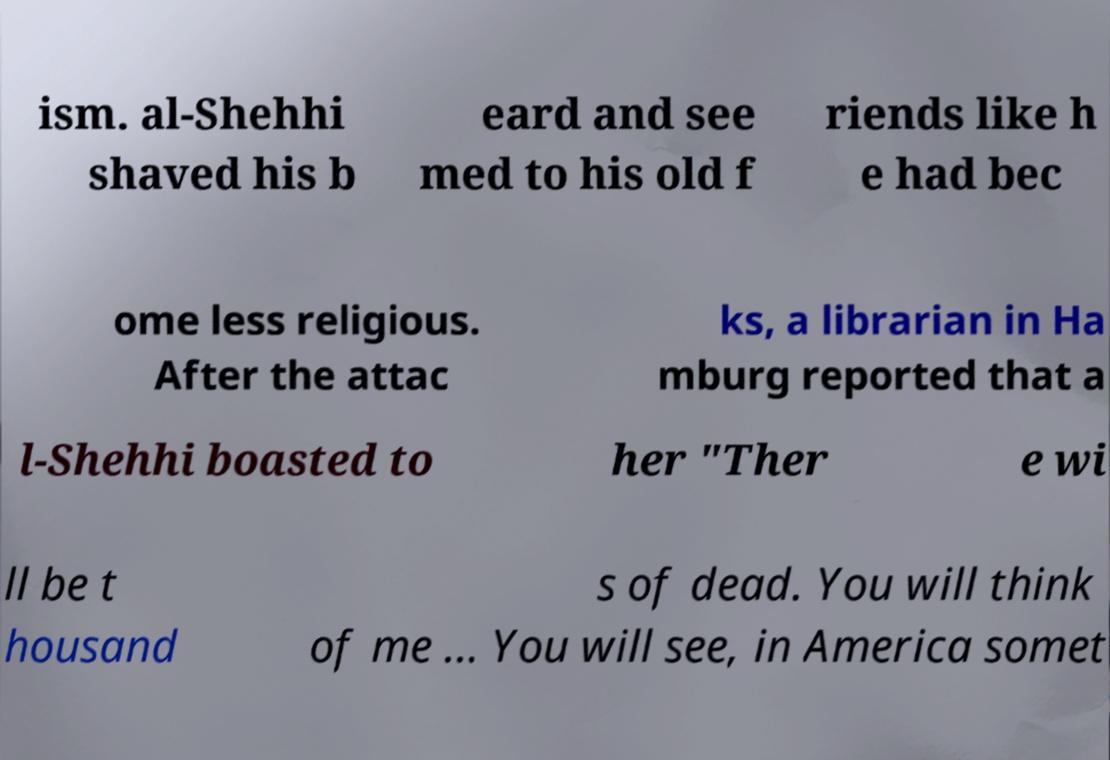Please read and relay the text visible in this image. What does it say? ism. al-Shehhi shaved his b eard and see med to his old f riends like h e had bec ome less religious. After the attac ks, a librarian in Ha mburg reported that a l-Shehhi boasted to her "Ther e wi ll be t housand s of dead. You will think of me ... You will see, in America somet 